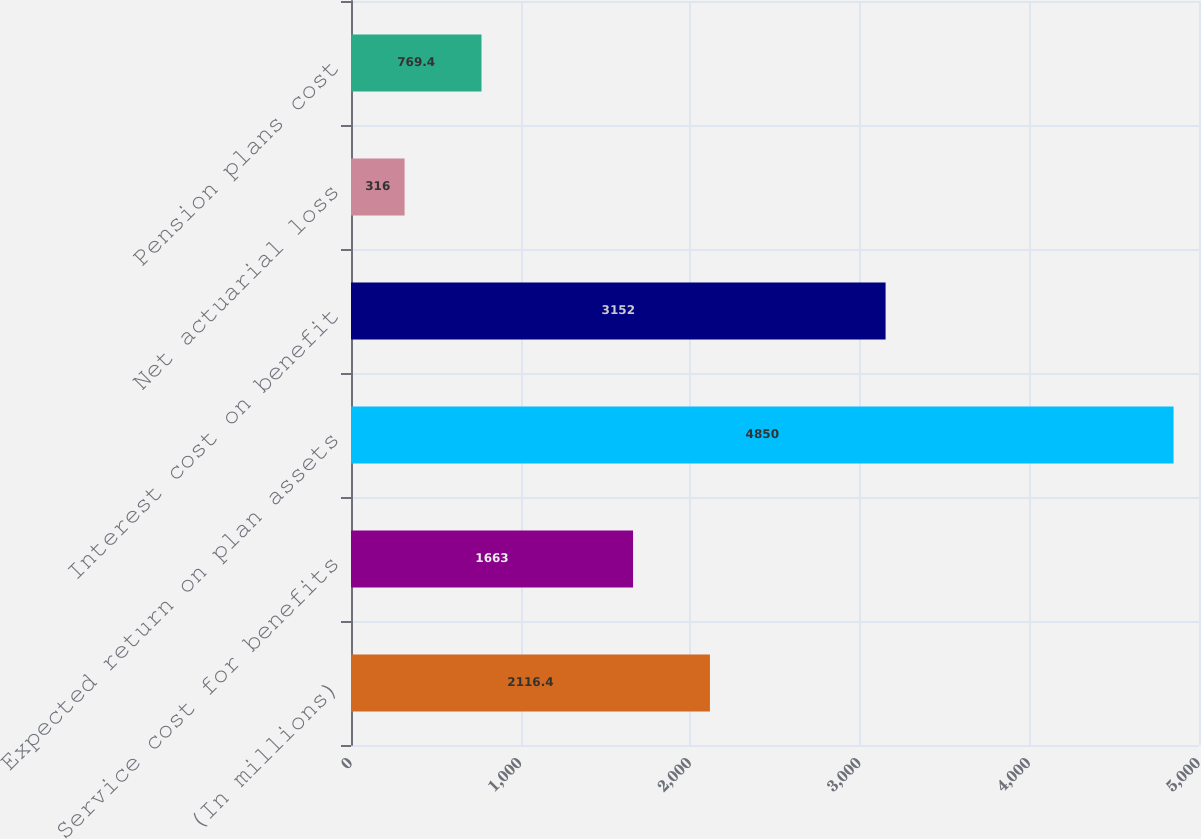Convert chart to OTSL. <chart><loc_0><loc_0><loc_500><loc_500><bar_chart><fcel>(In millions)<fcel>Service cost for benefits<fcel>Expected return on plan assets<fcel>Interest cost on benefit<fcel>Net actuarial loss<fcel>Pension plans cost<nl><fcel>2116.4<fcel>1663<fcel>4850<fcel>3152<fcel>316<fcel>769.4<nl></chart> 